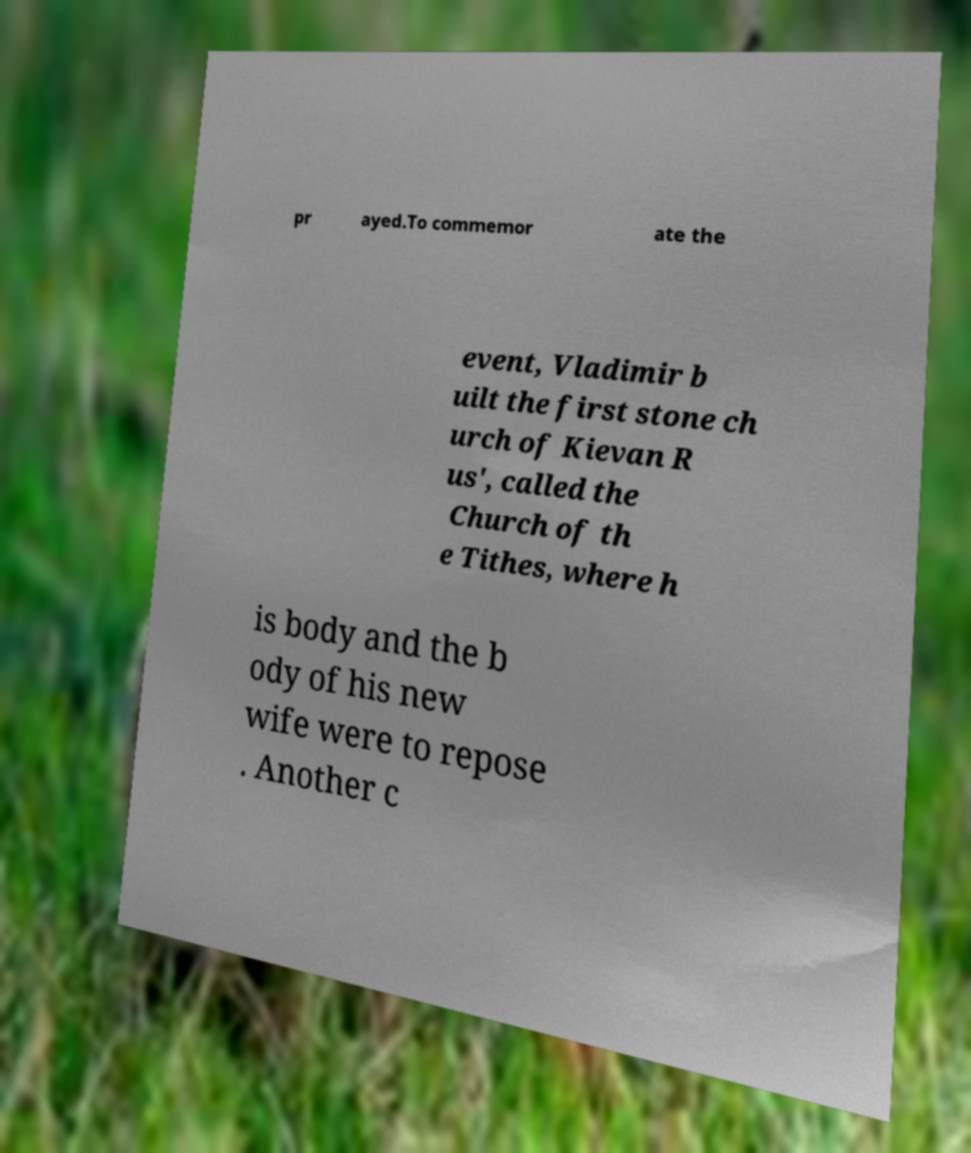Please identify and transcribe the text found in this image. pr ayed.To commemor ate the event, Vladimir b uilt the first stone ch urch of Kievan R us', called the Church of th e Tithes, where h is body and the b ody of his new wife were to repose . Another c 